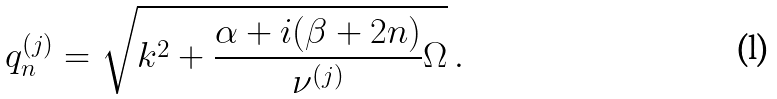<formula> <loc_0><loc_0><loc_500><loc_500>q _ { n } ^ { ( j ) } = \sqrt { k ^ { 2 } + \frac { \alpha + i ( \beta + 2 n ) } { \nu ^ { ( j ) } } \Omega } \, .</formula> 